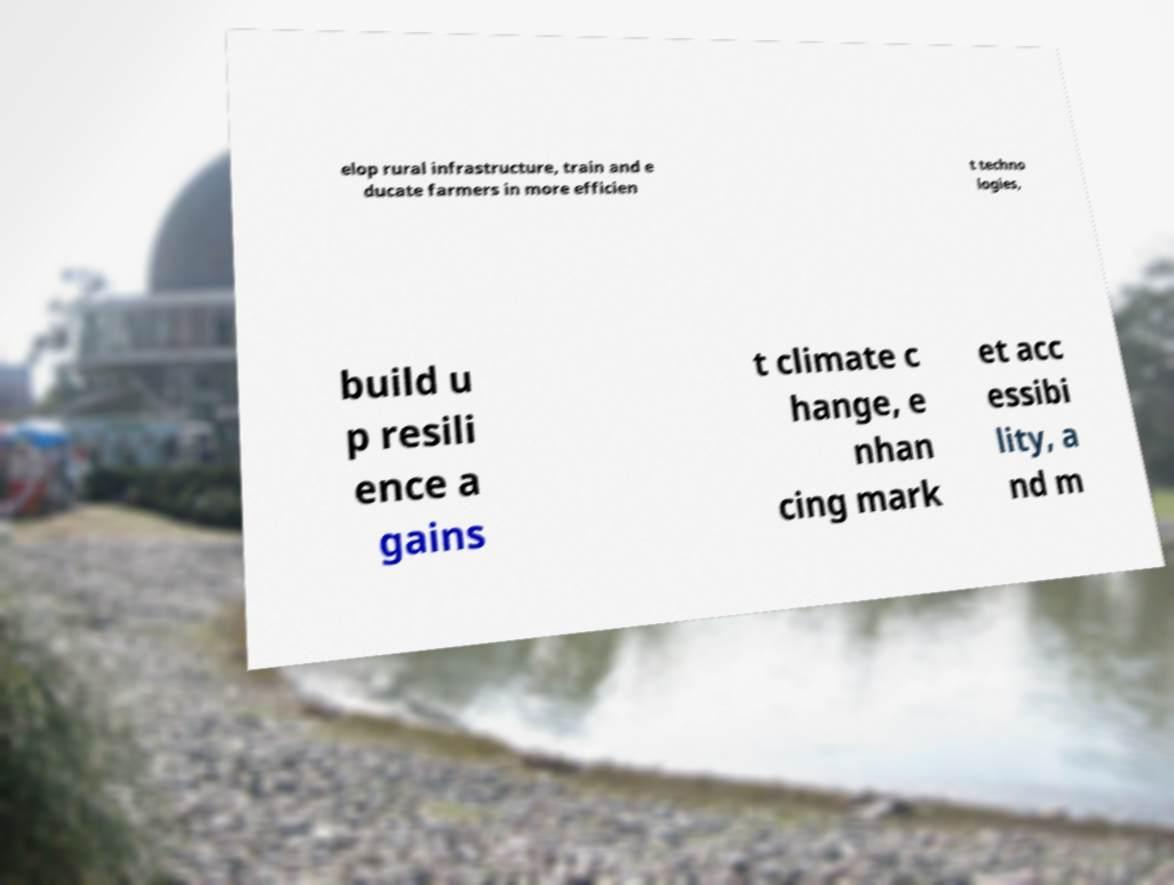There's text embedded in this image that I need extracted. Can you transcribe it verbatim? elop rural infrastructure, train and e ducate farmers in more efficien t techno logies, build u p resili ence a gains t climate c hange, e nhan cing mark et acc essibi lity, a nd m 